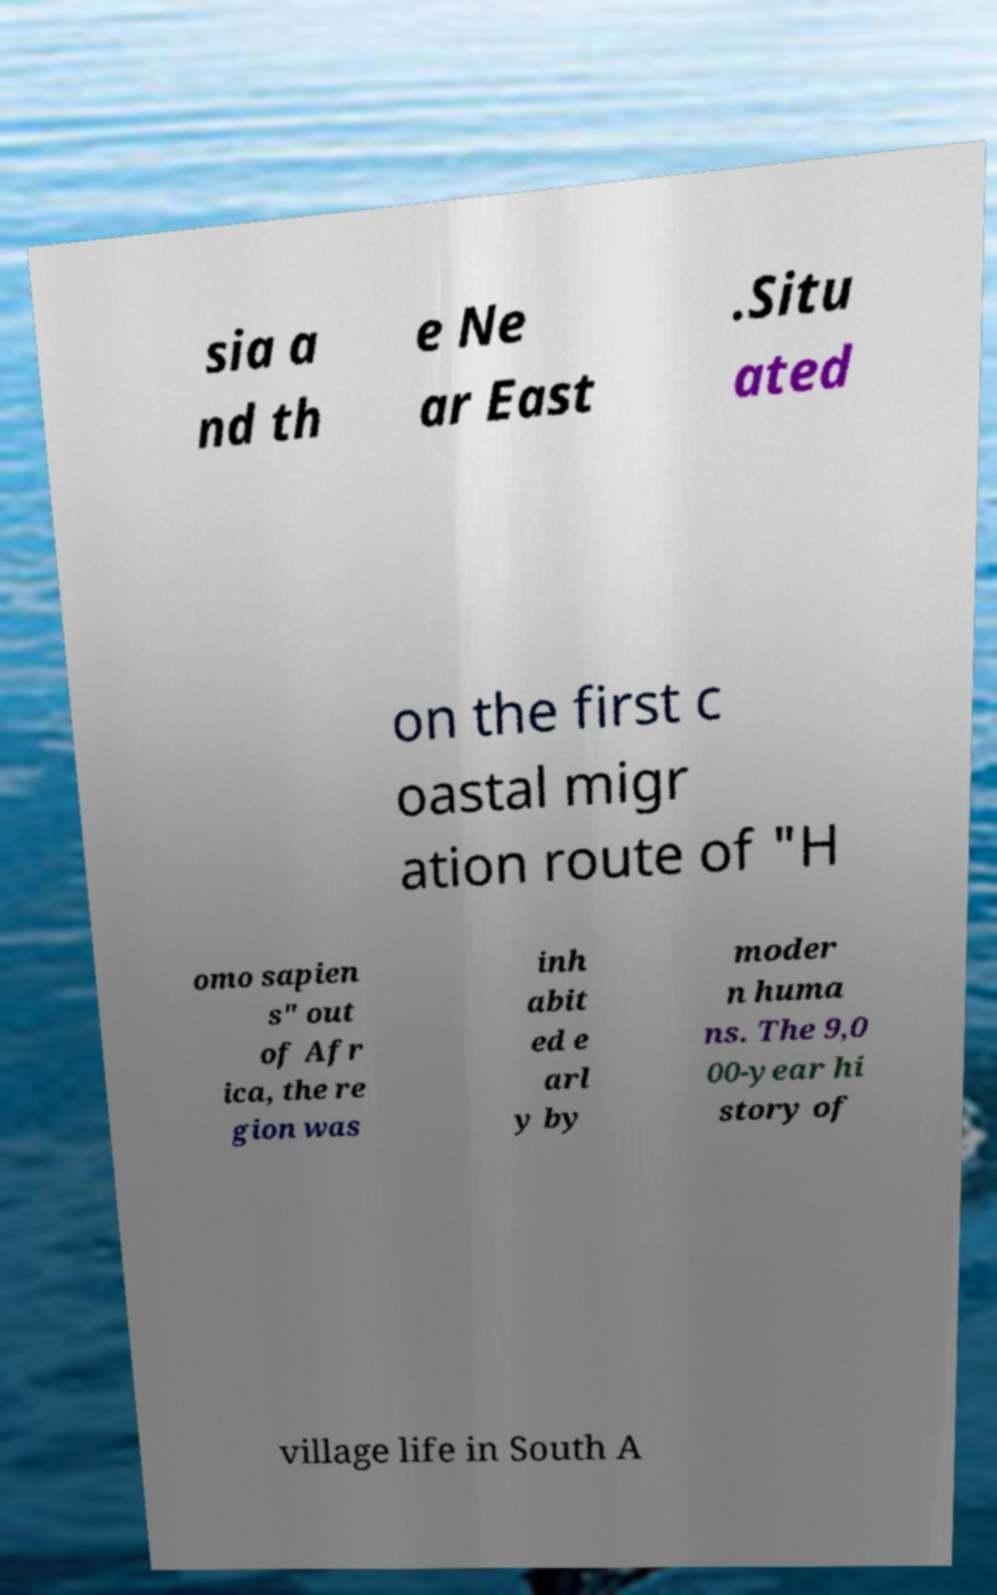Can you accurately transcribe the text from the provided image for me? sia a nd th e Ne ar East .Situ ated on the first c oastal migr ation route of "H omo sapien s" out of Afr ica, the re gion was inh abit ed e arl y by moder n huma ns. The 9,0 00-year hi story of village life in South A 